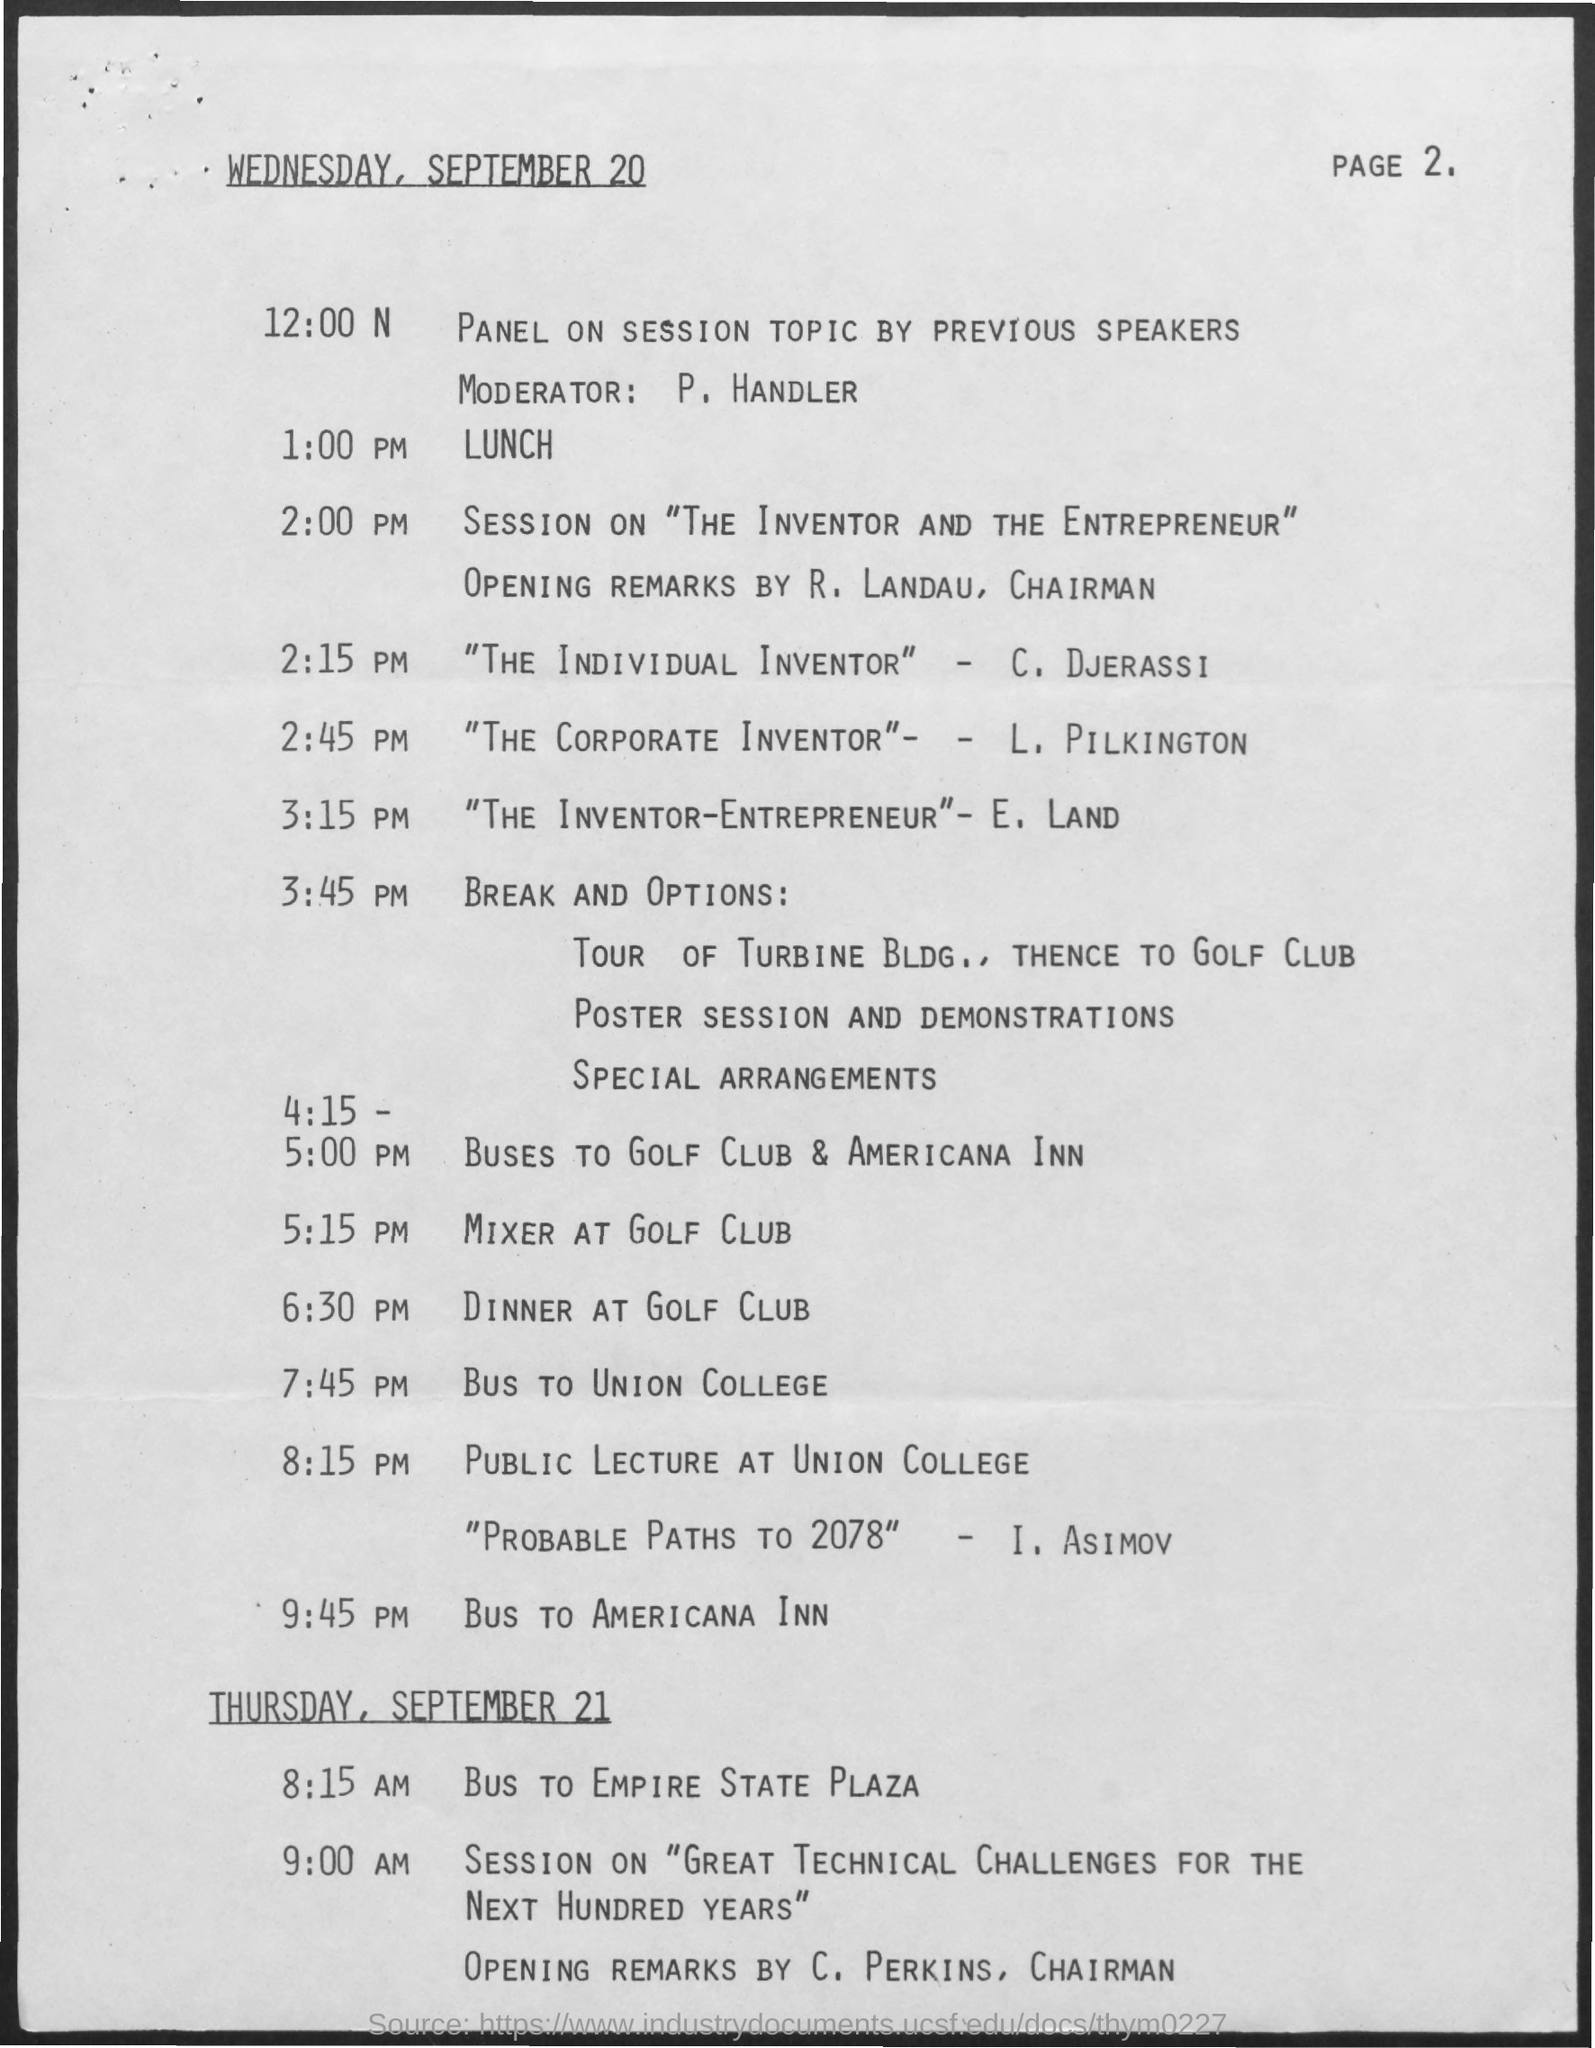What is the date mentioned in the top of the document?
Your answer should be compact. Wednesday, September 20. 